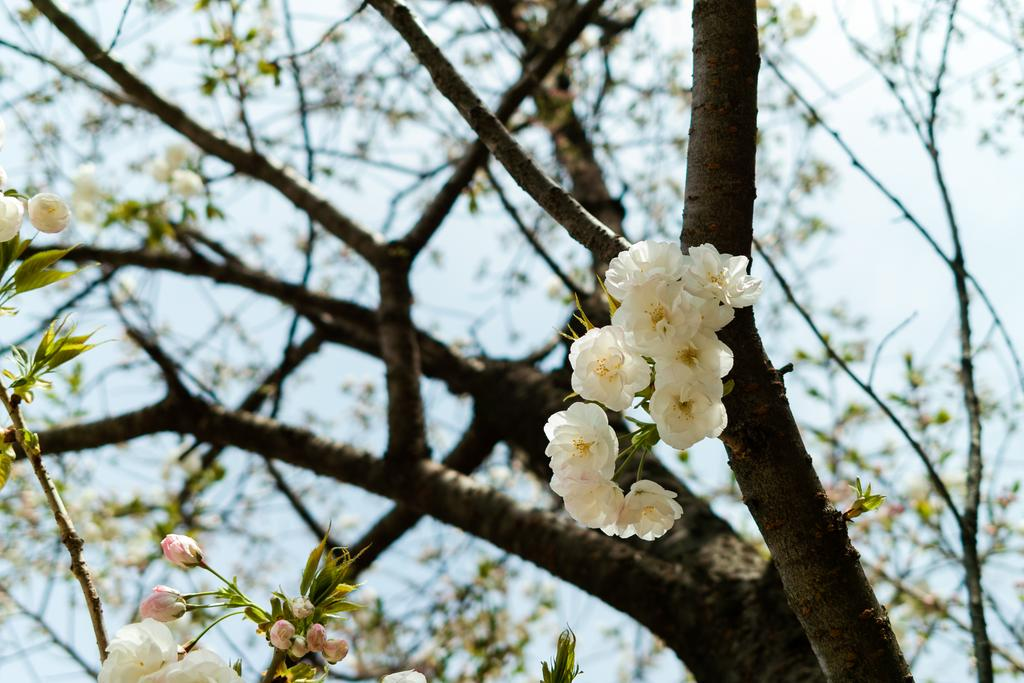What type of plant can be seen in the image? There is a tree in the image. Can you describe the tree's features? The tree has branches, leaves, and flowers. What is visible in the background of the image? The sky is visible in the background of the image. What direction is the tree facing in the image? The direction the tree is facing cannot be determined from the image, as it is a stationary object. Can you see a badge on the tree in the image? There is no badge present on the tree in the image. 